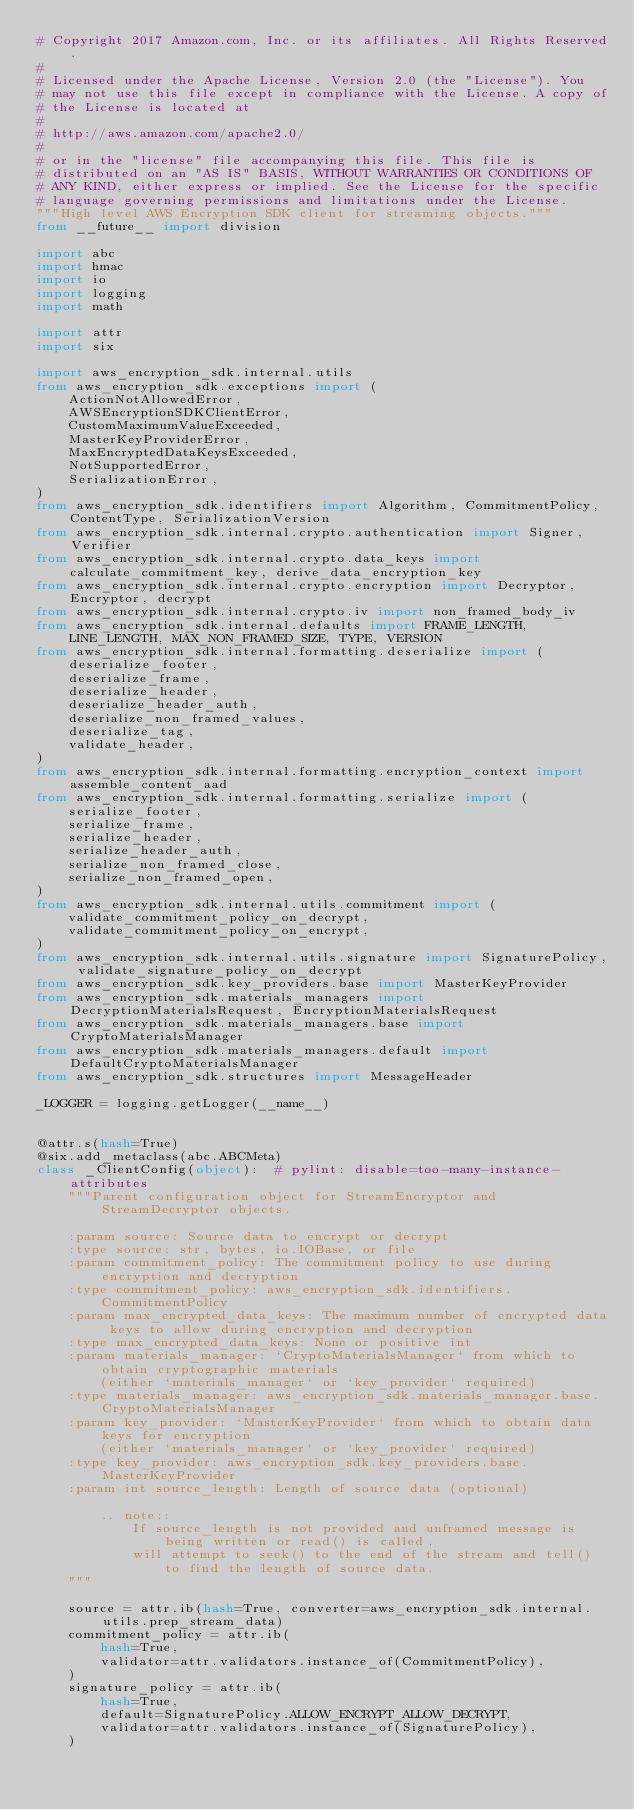Convert code to text. <code><loc_0><loc_0><loc_500><loc_500><_Python_># Copyright 2017 Amazon.com, Inc. or its affiliates. All Rights Reserved.
#
# Licensed under the Apache License, Version 2.0 (the "License"). You
# may not use this file except in compliance with the License. A copy of
# the License is located at
#
# http://aws.amazon.com/apache2.0/
#
# or in the "license" file accompanying this file. This file is
# distributed on an "AS IS" BASIS, WITHOUT WARRANTIES OR CONDITIONS OF
# ANY KIND, either express or implied. See the License for the specific
# language governing permissions and limitations under the License.
"""High level AWS Encryption SDK client for streaming objects."""
from __future__ import division

import abc
import hmac
import io
import logging
import math

import attr
import six

import aws_encryption_sdk.internal.utils
from aws_encryption_sdk.exceptions import (
    ActionNotAllowedError,
    AWSEncryptionSDKClientError,
    CustomMaximumValueExceeded,
    MasterKeyProviderError,
    MaxEncryptedDataKeysExceeded,
    NotSupportedError,
    SerializationError,
)
from aws_encryption_sdk.identifiers import Algorithm, CommitmentPolicy, ContentType, SerializationVersion
from aws_encryption_sdk.internal.crypto.authentication import Signer, Verifier
from aws_encryption_sdk.internal.crypto.data_keys import calculate_commitment_key, derive_data_encryption_key
from aws_encryption_sdk.internal.crypto.encryption import Decryptor, Encryptor, decrypt
from aws_encryption_sdk.internal.crypto.iv import non_framed_body_iv
from aws_encryption_sdk.internal.defaults import FRAME_LENGTH, LINE_LENGTH, MAX_NON_FRAMED_SIZE, TYPE, VERSION
from aws_encryption_sdk.internal.formatting.deserialize import (
    deserialize_footer,
    deserialize_frame,
    deserialize_header,
    deserialize_header_auth,
    deserialize_non_framed_values,
    deserialize_tag,
    validate_header,
)
from aws_encryption_sdk.internal.formatting.encryption_context import assemble_content_aad
from aws_encryption_sdk.internal.formatting.serialize import (
    serialize_footer,
    serialize_frame,
    serialize_header,
    serialize_header_auth,
    serialize_non_framed_close,
    serialize_non_framed_open,
)
from aws_encryption_sdk.internal.utils.commitment import (
    validate_commitment_policy_on_decrypt,
    validate_commitment_policy_on_encrypt,
)
from aws_encryption_sdk.internal.utils.signature import SignaturePolicy, validate_signature_policy_on_decrypt
from aws_encryption_sdk.key_providers.base import MasterKeyProvider
from aws_encryption_sdk.materials_managers import DecryptionMaterialsRequest, EncryptionMaterialsRequest
from aws_encryption_sdk.materials_managers.base import CryptoMaterialsManager
from aws_encryption_sdk.materials_managers.default import DefaultCryptoMaterialsManager
from aws_encryption_sdk.structures import MessageHeader

_LOGGER = logging.getLogger(__name__)


@attr.s(hash=True)
@six.add_metaclass(abc.ABCMeta)
class _ClientConfig(object):  # pylint: disable=too-many-instance-attributes
    """Parent configuration object for StreamEncryptor and StreamDecryptor objects.

    :param source: Source data to encrypt or decrypt
    :type source: str, bytes, io.IOBase, or file
    :param commitment_policy: The commitment policy to use during encryption and decryption
    :type commitment_policy: aws_encryption_sdk.identifiers.CommitmentPolicy
    :param max_encrypted_data_keys: The maximum number of encrypted data keys to allow during encryption and decryption
    :type max_encrypted_data_keys: None or positive int
    :param materials_manager: `CryptoMaterialsManager` from which to obtain cryptographic materials
        (either `materials_manager` or `key_provider` required)
    :type materials_manager: aws_encryption_sdk.materials_manager.base.CryptoMaterialsManager
    :param key_provider: `MasterKeyProvider` from which to obtain data keys for encryption
        (either `materials_manager` or `key_provider` required)
    :type key_provider: aws_encryption_sdk.key_providers.base.MasterKeyProvider
    :param int source_length: Length of source data (optional)

        .. note::
            If source_length is not provided and unframed message is being written or read() is called,
            will attempt to seek() to the end of the stream and tell() to find the length of source data.
    """

    source = attr.ib(hash=True, converter=aws_encryption_sdk.internal.utils.prep_stream_data)
    commitment_policy = attr.ib(
        hash=True,
        validator=attr.validators.instance_of(CommitmentPolicy),
    )
    signature_policy = attr.ib(
        hash=True,
        default=SignaturePolicy.ALLOW_ENCRYPT_ALLOW_DECRYPT,
        validator=attr.validators.instance_of(SignaturePolicy),
    )</code> 